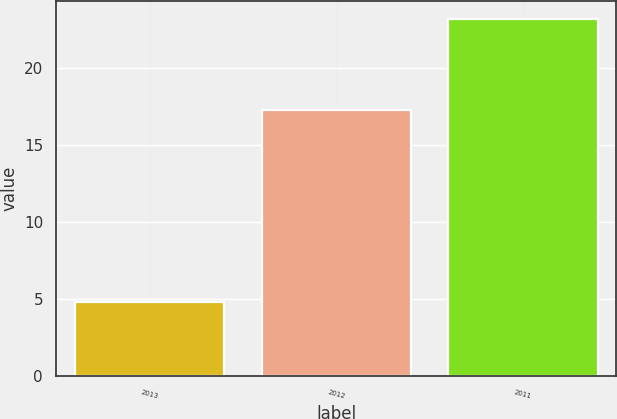Convert chart. <chart><loc_0><loc_0><loc_500><loc_500><bar_chart><fcel>2013<fcel>2012<fcel>2011<nl><fcel>4.8<fcel>17.3<fcel>23.2<nl></chart> 